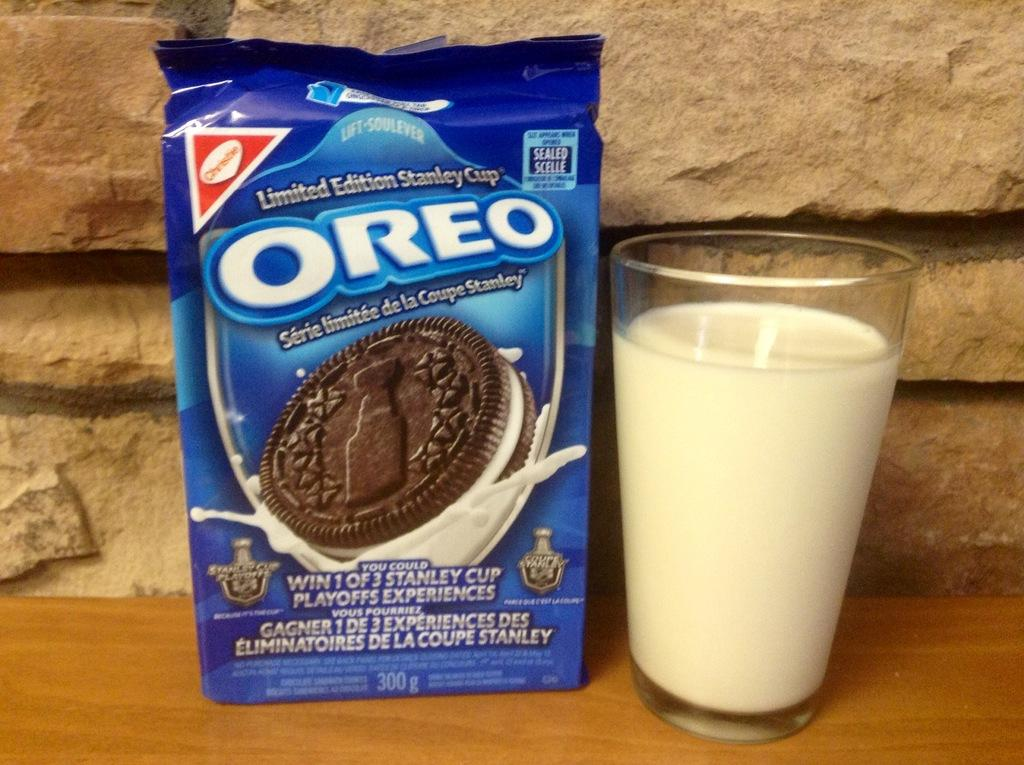What is in the glass that is visible in the picture? There is a glass of milk in the picture. What else can be seen in the picture besides the glass of milk? There is a blue color packet in the picture, which has a picture of a biscuit on it. What information is present on the packet? The packet has names on it. What type of surface are the objects placed on? The objects are on a wooden surface. What type of plants can be seen growing in the air in the picture? There are no plants visible in the picture, and the air is not mentioned as a location for any objects or elements. 